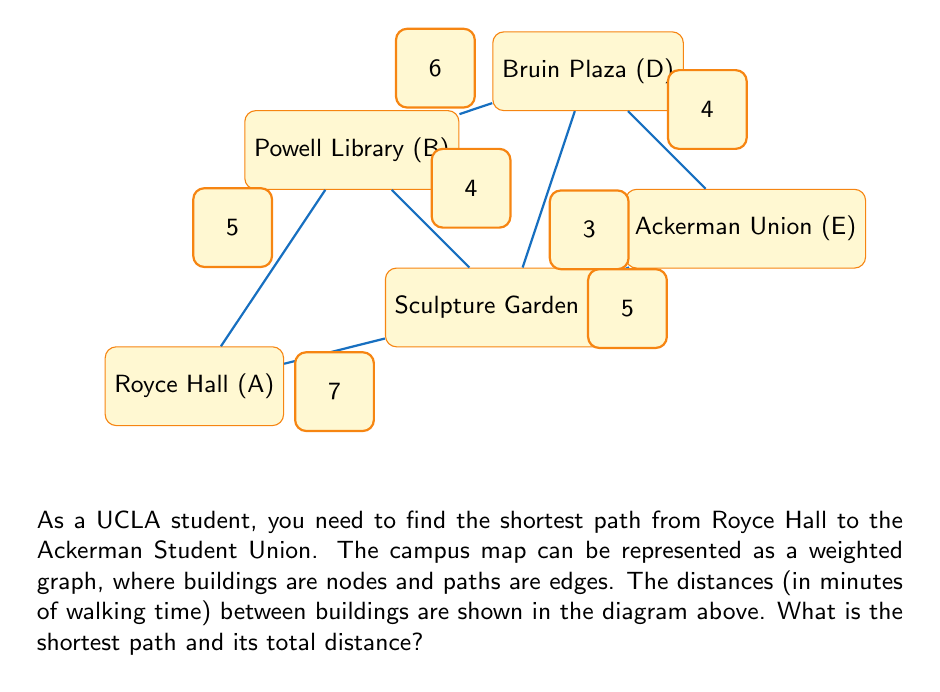Provide a solution to this math problem. To solve this problem, we'll use Dijkstra's algorithm, which is an efficient method for finding the shortest path in a weighted graph.

Step 1: Initialize distances
Let's assign labels to each node:
A: Royce Hall
B: Powell Library
C: Sculpture Garden
D: Bruin Plaza
E: Ackerman Union

Initialize distances:
A: 0 (starting point)
B, C, D, E: $\infty$ (unknown)

Step 2: Visit neighbors of A
Update distances:
B: 5
C: 7

Step 3: Visit the node with the smallest distance (B)
Update distances:
D: min($\infty$, 5 + 6) = 11
C: min(7, 5 + 4) = 7 (no change)

Step 4: Visit the node with the next smallest distance (C)
Update distances:
D: min(11, 7 + 3) = 10
E: min($\infty$, 7 + 5) = 12

Step 5: Visit D
Update distances:
E: min(12, 10 + 4) = 12 (no change)

Step 6: Visit E (destination reached)

The shortest path is A -> C -> D -> E with a total distance of 14 minutes.

To verify:
A -> C: 7 minutes
C -> D: 3 minutes
D -> E: 4 minutes
Total: 7 + 3 + 4 = 14 minutes
Answer: A -> C -> D -> E, 14 minutes 